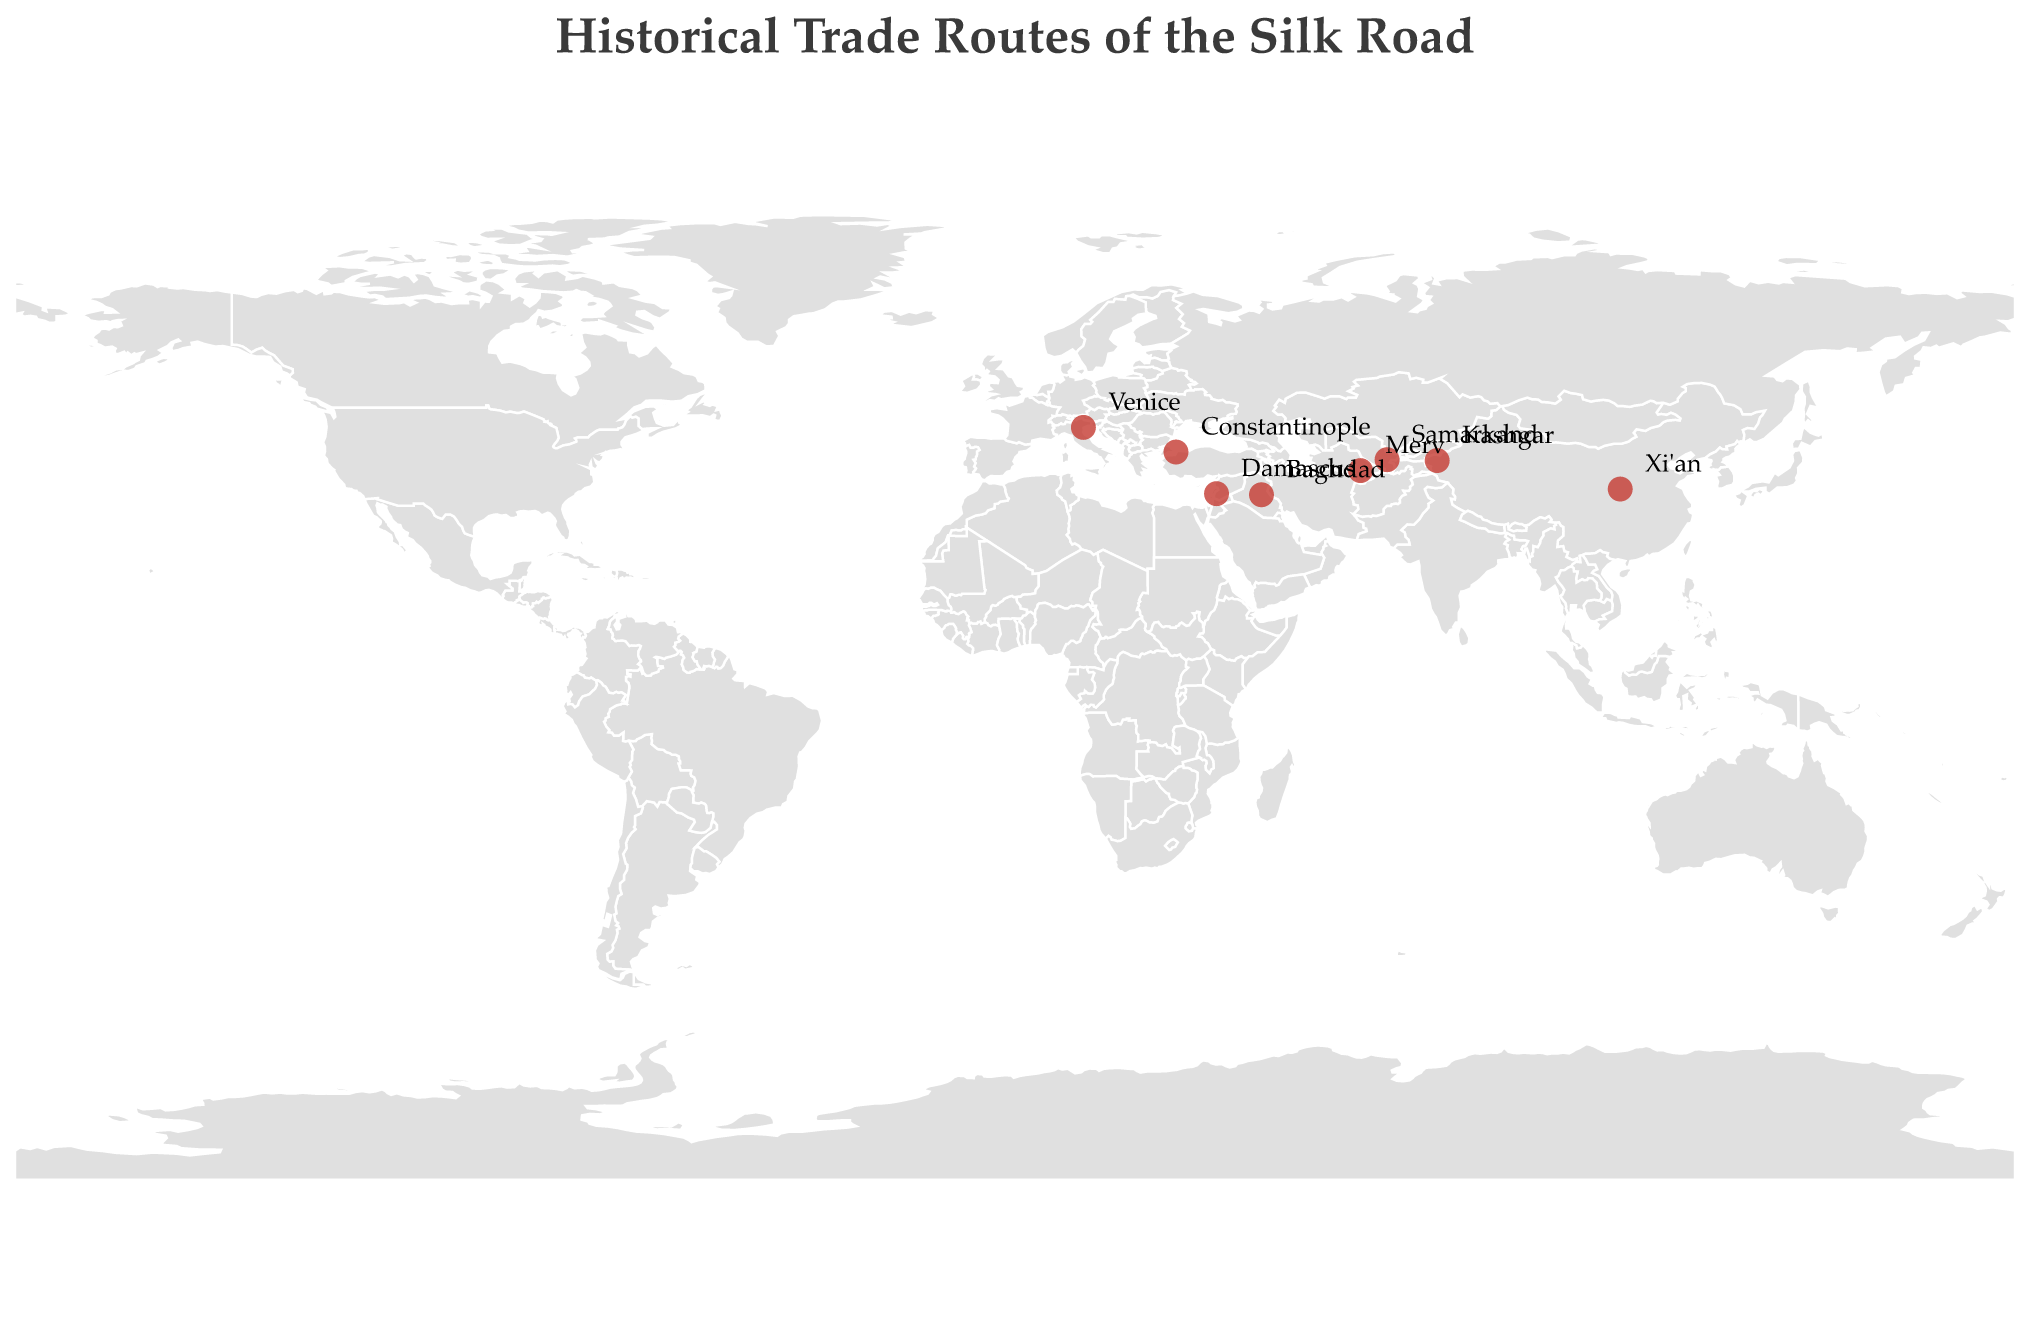What is the title of the geographic plot? The title is displayed at the top of the plot. It reads "Historical Trade Routes of the Silk Road".
Answer: Historical Trade Routes of the Silk Road How many cities are shown on the map? The map features 8 cities, indicated by red circles. These cities are Xi'an, Kashgar, Samarkand, Merv, Baghdad, Damascus, Constantinople, and Venice.
Answer: 8 Which city is located at the highest latitude? The city located at the highest latitude is the one with the greatest latitude value. Venice, at a latitude of 45.4408, is the highest.
Answer: Venice What goods were exported by Xi'an? By looking at the tooltip information for Xi'an, we see that the primary export good was Silk.
Answer: Silk Which two cities export Glassware? From the tooltip information, both Kashmir and Constantinople are shown to export Glassware.
Answer: Kashgar and Constantinople Which city imports Precious Stones and what does it export? By referring to the tooltip information for Merv, we see that it imports Precious Stones and exports Textiles.
Answer: Merv; Textiles What is the average longitude of all the cities plotted? Calculate the sum of the longitudes of all cities and divide by the number of cities. Sum: 108.9398 + 75.9897 + 66.9750 + 62.1914 + 44.3661 + 36.2765 + 28.9784 + 12.3155 = 436.0324. Average: 436.0324 / 8 = 54.50405.
Answer: 54.50405 Compare the goods exported by Xi'an and Baghdad. Are they the same or different? The tooltip information shows that Xi'an exports Silk, while Baghdad exports Carpets, so they are different.
Answer: Different What kind of projection is used in the map to display the geographic information? The map uses an equirectangular projection, which is specified in the projection details of the plot.
Answer: Equirectangular Which goods were imported by Damascus and which city exported those goods? The tooltip for Damascus shows it imports Tea. By examining the export goods of other cities, none specifically export Tea, so no specific export city can be identified based on the visual data.
Answer: Tea; Unknown exporting city 